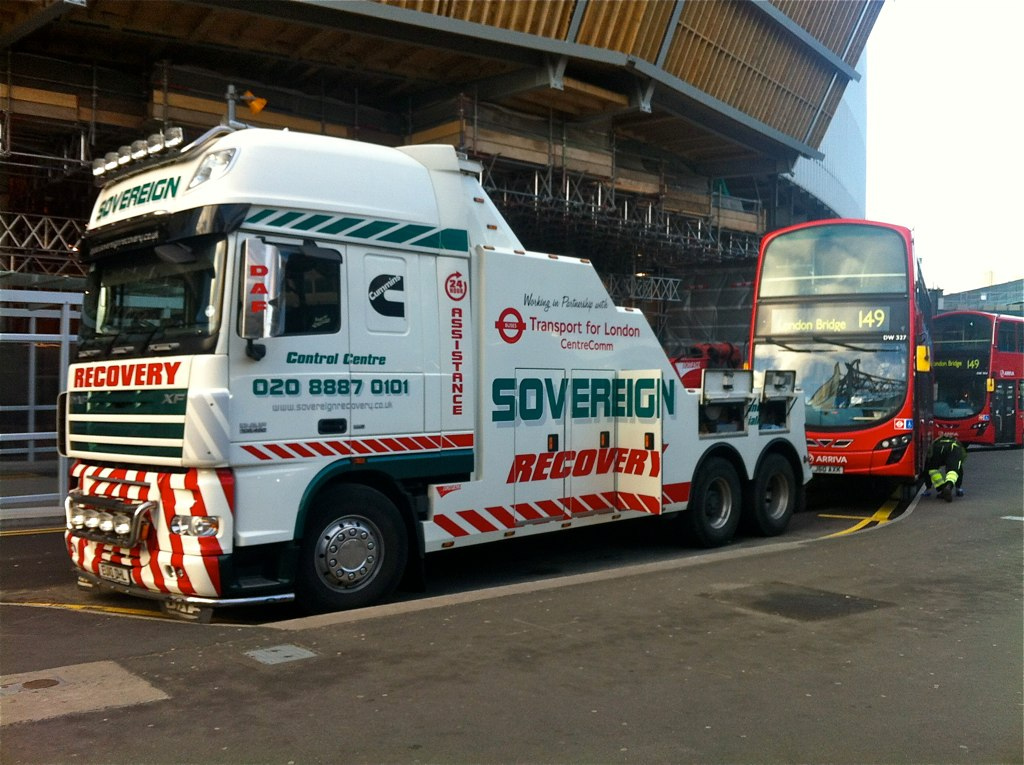What can you infer about the truck's location from the image? The truck is in an urban environment, possibly at a bus depot or station, as indicated by the number of red double-decker buses in the background that are common in London. The text on the bus says 'London Bridge,' suggesting the truck might be somewhere in the vicinity of London Bridge. Is the presence of this truck indicative of an issue with one of the buses? While the truck's presence could suggest a bus breakdown or the need for vehicle recovery, there's no direct evidence of an issue with any particular bus in the image. The truck could also be on standby or in between recovery tasks. 